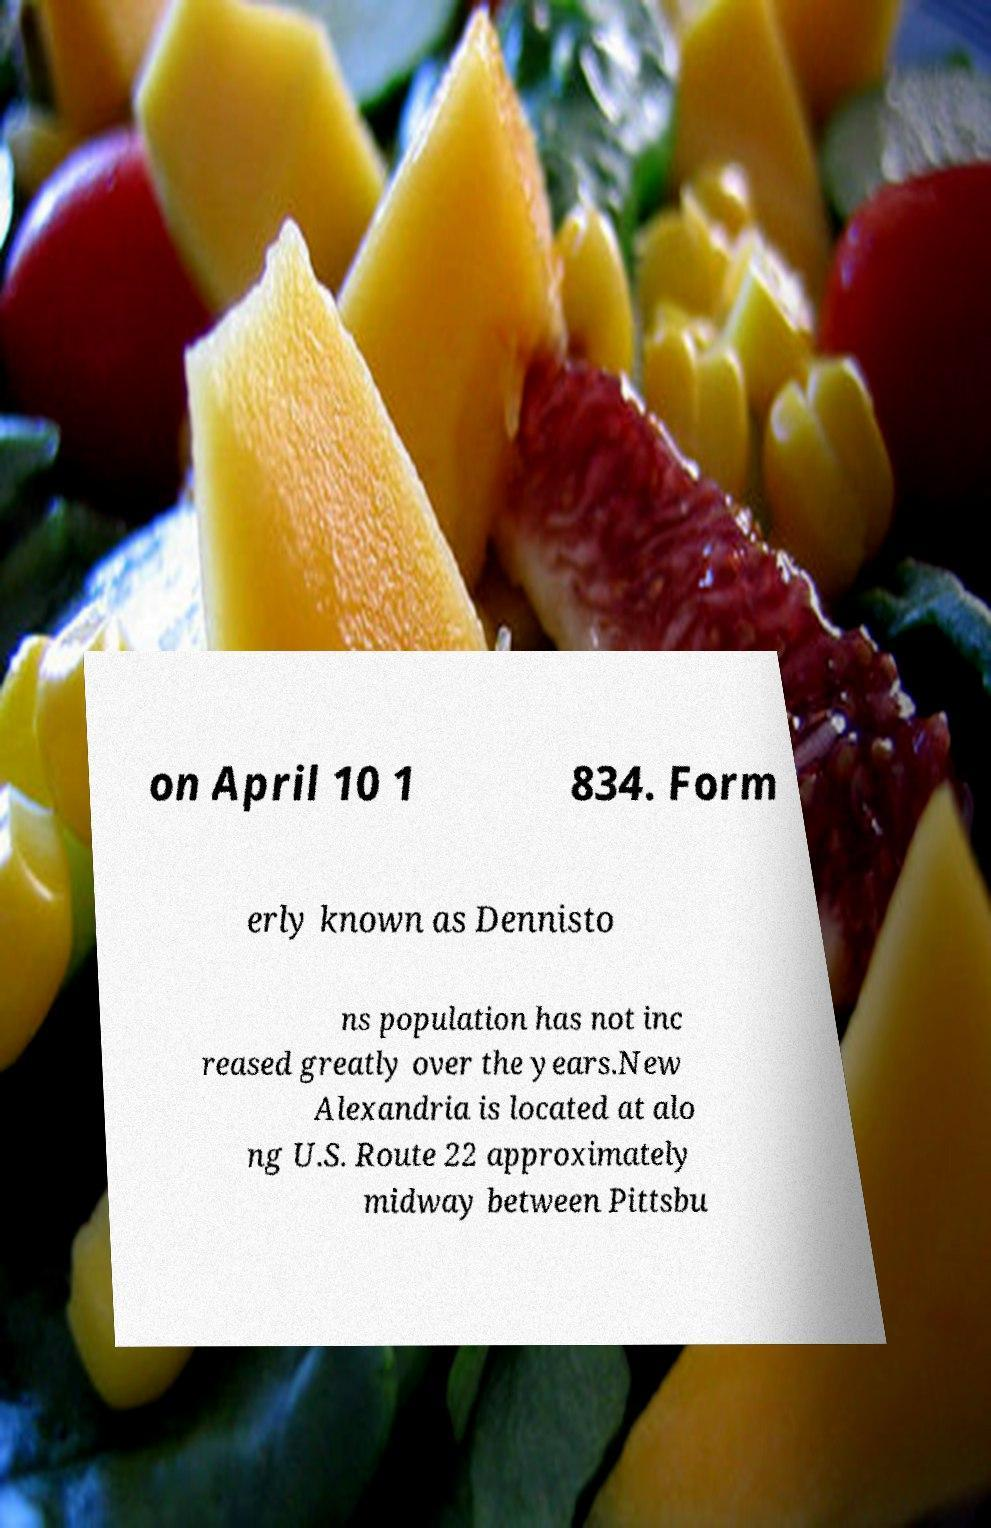Please read and relay the text visible in this image. What does it say? on April 10 1 834. Form erly known as Dennisto ns population has not inc reased greatly over the years.New Alexandria is located at alo ng U.S. Route 22 approximately midway between Pittsbu 